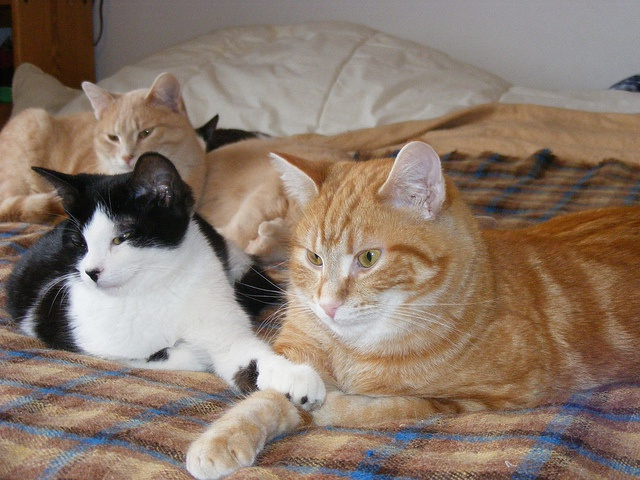Describe the objects in this image and their specific colors. I can see bed in black, gray, and darkgray tones, cat in black, gray, tan, maroon, and darkgray tones, cat in black, lightgray, darkgray, and gray tones, cat in black, gray, darkgray, and tan tones, and cat in black and gray tones in this image. 